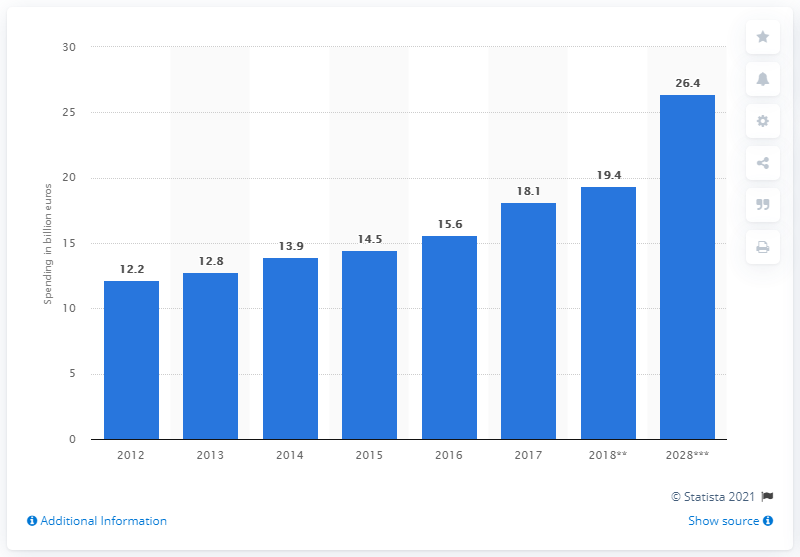Mention a couple of crucial points in this snapshot. The expected increase in international visitors in Portugal in 2018 is 19.4%. In 2017, international visitors spent 18.1 billion euros in Portugal. 